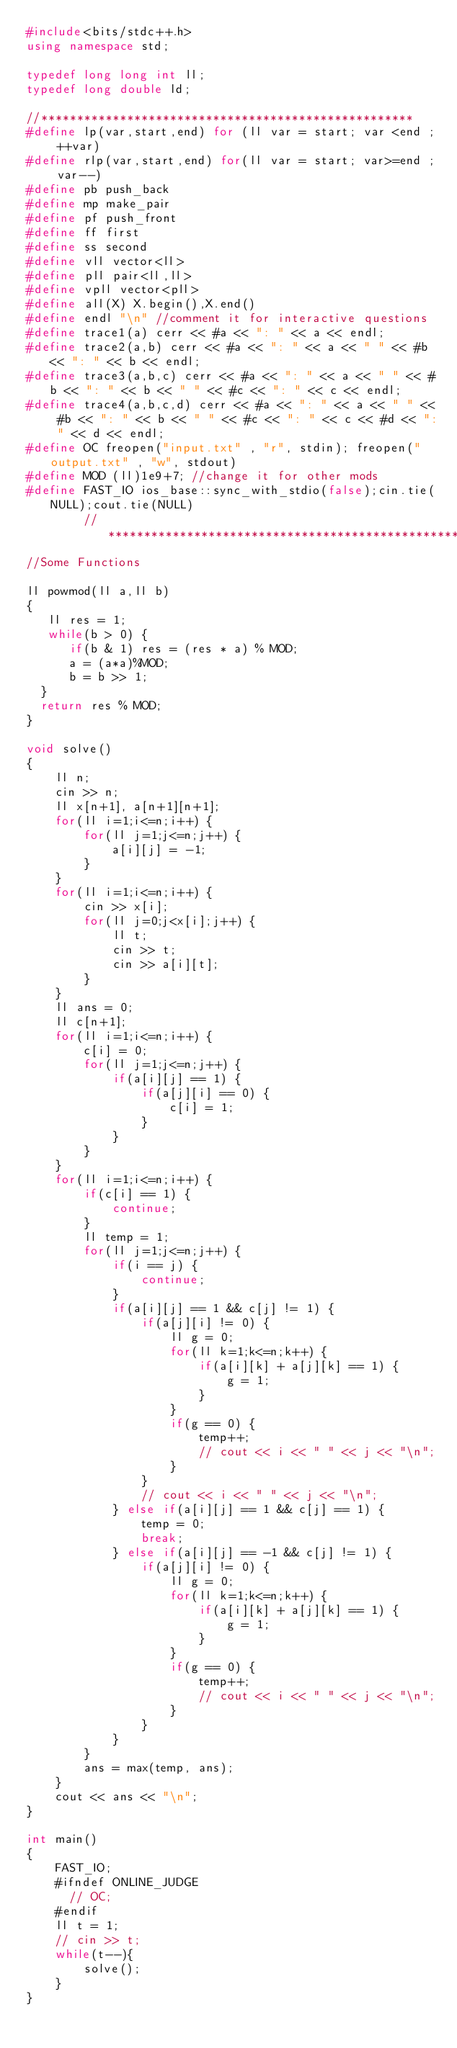<code> <loc_0><loc_0><loc_500><loc_500><_C++_>#include<bits/stdc++.h>
using namespace std;

typedef long long int ll;
typedef long double ld;

//****************************************************                
#define lp(var,start,end) for (ll var = start; var <end ; ++var)
#define rlp(var,start,end) for(ll var = start; var>=end ; var--)
#define pb push_back
#define mp make_pair
#define pf push_front
#define ff first
#define ss second
#define vll vector<ll>
#define pll pair<ll,ll> 
#define vpll vector<pll>
#define all(X) X.begin(),X.end()
#define endl "\n" //comment it for interactive questions
#define trace1(a) cerr << #a << ": " << a << endl;
#define trace2(a,b) cerr << #a << ": " << a << " " << #b << ": " << b << endl;
#define trace3(a,b,c) cerr << #a << ": " << a << " " << #b << ": " << b << " " << #c << ": " << c << endl;
#define trace4(a,b,c,d) cerr << #a << ": " << a << " " << #b << ": " << b << " " << #c << ": " << c << #d << ": " << d << endl;
#define OC freopen("input.txt" , "r", stdin); freopen("output.txt" , "w", stdout) 
#define MOD (ll)1e9+7; //change it for other mods
#define FAST_IO ios_base::sync_with_stdio(false);cin.tie(NULL);cout.tie(NULL)
        //*******************************************************
//Some Functions

ll powmod(ll a,ll b)
{
   ll res = 1;
   while(b > 0) {
      if(b & 1) res = (res * a) % MOD;
      a = (a*a)%MOD;
      b = b >> 1; 
  }
  return res % MOD;
}

void solve()
{
    ll n;
    cin >> n;
    ll x[n+1], a[n+1][n+1];
    for(ll i=1;i<=n;i++) {
        for(ll j=1;j<=n;j++) {
            a[i][j] = -1;
        }
    }
    for(ll i=1;i<=n;i++) {
        cin >> x[i];
        for(ll j=0;j<x[i];j++) {
            ll t;
            cin >> t;
            cin >> a[i][t];
        }
    }
    ll ans = 0;
    ll c[n+1];
    for(ll i=1;i<=n;i++) {
        c[i] = 0;
        for(ll j=1;j<=n;j++) {
            if(a[i][j] == 1) {
                if(a[j][i] == 0) {
                    c[i] = 1;
                }
            }
        }
    }
    for(ll i=1;i<=n;i++) {
        if(c[i] == 1) {
            continue;
        }
        ll temp = 1;
        for(ll j=1;j<=n;j++) {
            if(i == j) {
                continue;
            }
            if(a[i][j] == 1 && c[j] != 1) {
                if(a[j][i] != 0) {
                    ll g = 0;
                    for(ll k=1;k<=n;k++) {
                        if(a[i][k] + a[j][k] == 1) {
                            g = 1;
                        }
                    }
                    if(g == 0) {
                        temp++;
                        // cout << i << " " << j << "\n";
                    }
                }
                // cout << i << " " << j << "\n";
            } else if(a[i][j] == 1 && c[j] == 1) {
                temp = 0;
                break;
            } else if(a[i][j] == -1 && c[j] != 1) {
                if(a[j][i] != 0) {
                    ll g = 0;
                    for(ll k=1;k<=n;k++) {
                        if(a[i][k] + a[j][k] == 1) {
                            g = 1;
                        }
                    }
                    if(g == 0) {
                        temp++;
                        // cout << i << " " << j << "\n";
                    }
                } 
            }
        }
        ans = max(temp, ans);
    }
    cout << ans << "\n";
}

int main()
{
    FAST_IO;
    #ifndef ONLINE_JUDGE 
      // OC;
    #endif
    ll t = 1;
    // cin >> t;
    while(t--){
        solve();
    }
}</code> 